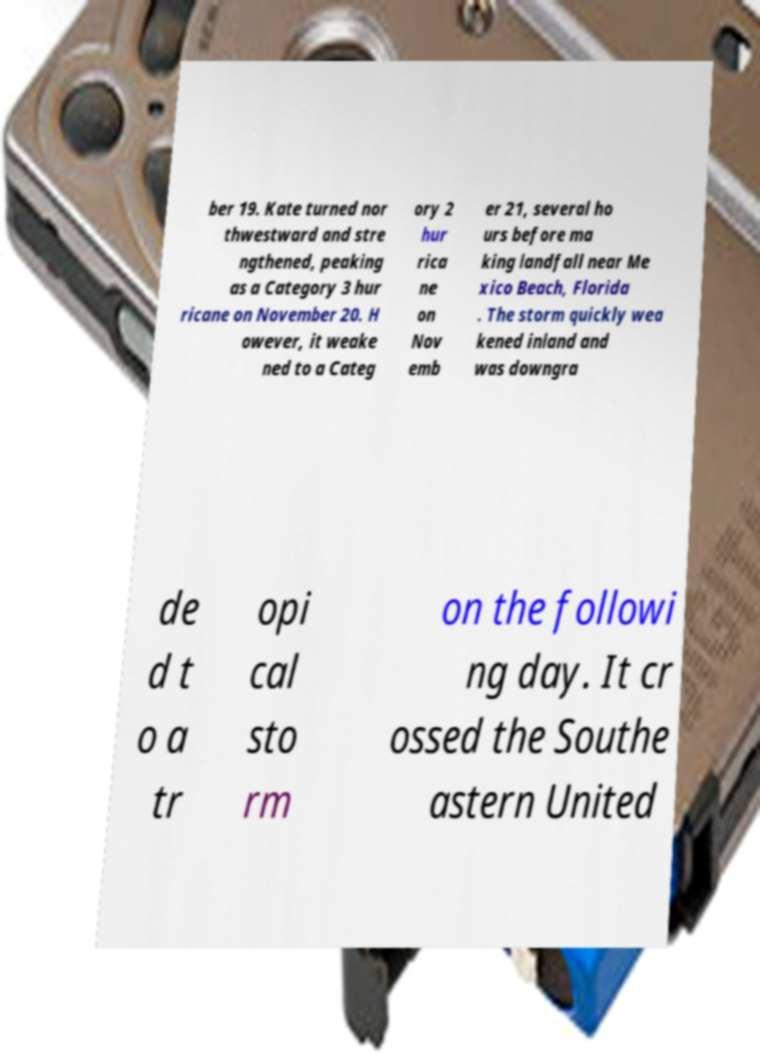What messages or text are displayed in this image? I need them in a readable, typed format. ber 19. Kate turned nor thwestward and stre ngthened, peaking as a Category 3 hur ricane on November 20. H owever, it weake ned to a Categ ory 2 hur rica ne on Nov emb er 21, several ho urs before ma king landfall near Me xico Beach, Florida . The storm quickly wea kened inland and was downgra de d t o a tr opi cal sto rm on the followi ng day. It cr ossed the Southe astern United 